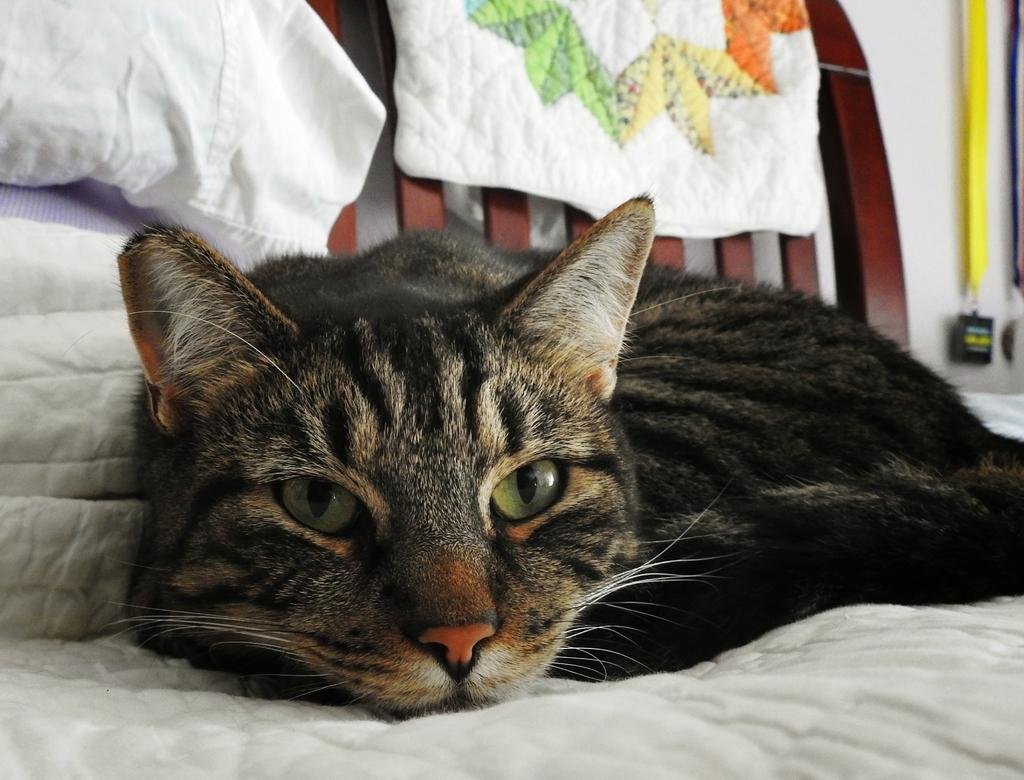What type of animal is in the image? There is a cat in the image. What color is the surface at the bottom of the image? The surface at the bottom of the image is white. What can be seen in the background of the image? In the background of the image, there are clothes, a wall, a wooden object, and other objects. How many cherries are growing on the cat's arm in the image? There are no cherries or growth visible on the cat's arm in the image, as it is a cat and not a plant or human. 